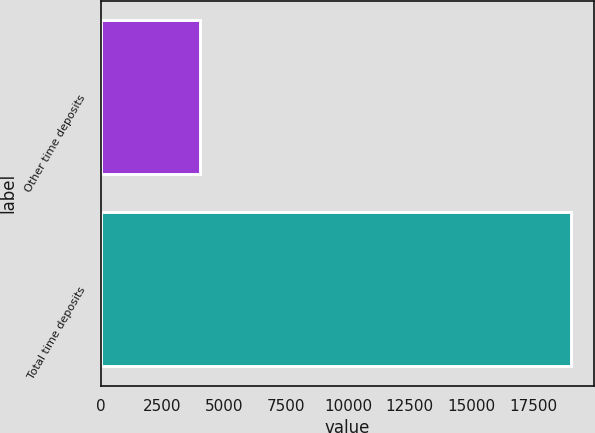Convert chart. <chart><loc_0><loc_0><loc_500><loc_500><bar_chart><fcel>Other time deposits<fcel>Total time deposits<nl><fcel>4027<fcel>19013<nl></chart> 